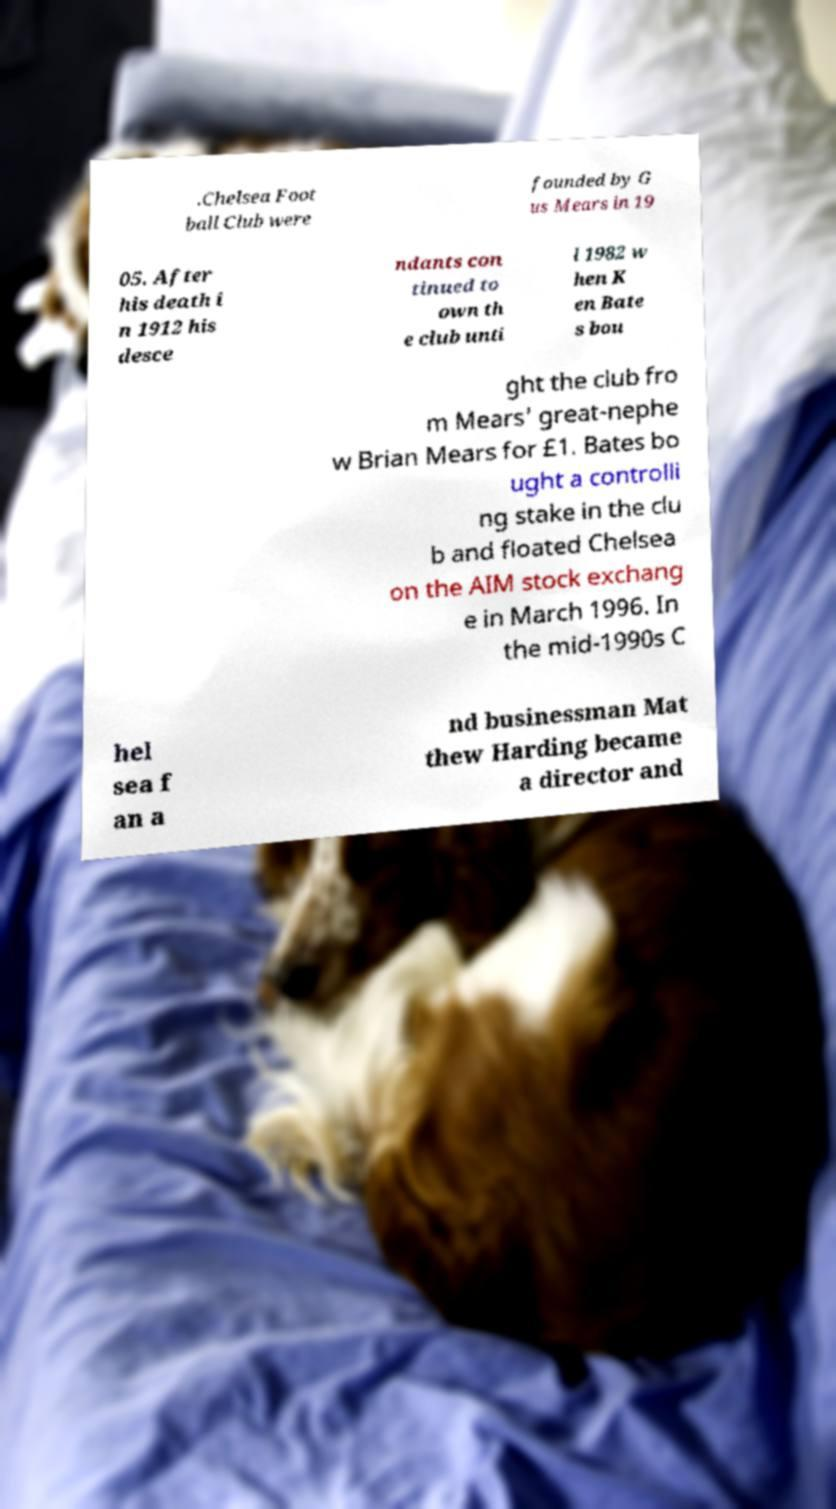There's text embedded in this image that I need extracted. Can you transcribe it verbatim? .Chelsea Foot ball Club were founded by G us Mears in 19 05. After his death i n 1912 his desce ndants con tinued to own th e club unti l 1982 w hen K en Bate s bou ght the club fro m Mears' great-nephe w Brian Mears for £1. Bates bo ught a controlli ng stake in the clu b and floated Chelsea on the AIM stock exchang e in March 1996. In the mid-1990s C hel sea f an a nd businessman Mat thew Harding became a director and 